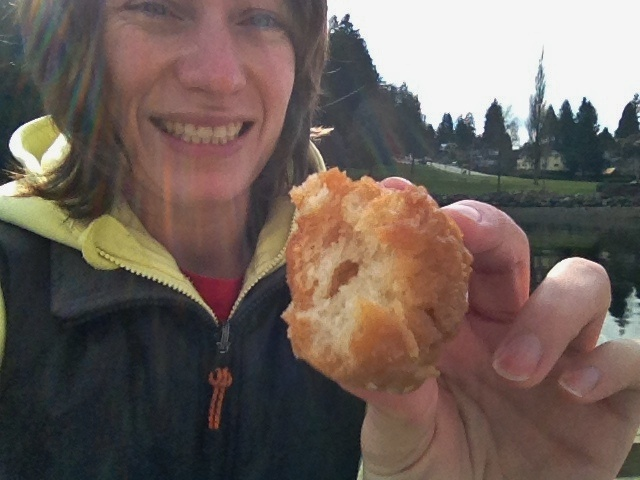Describe the objects in this image and their specific colors. I can see people in gray, black, brown, and maroon tones and donut in gray, brown, and tan tones in this image. 